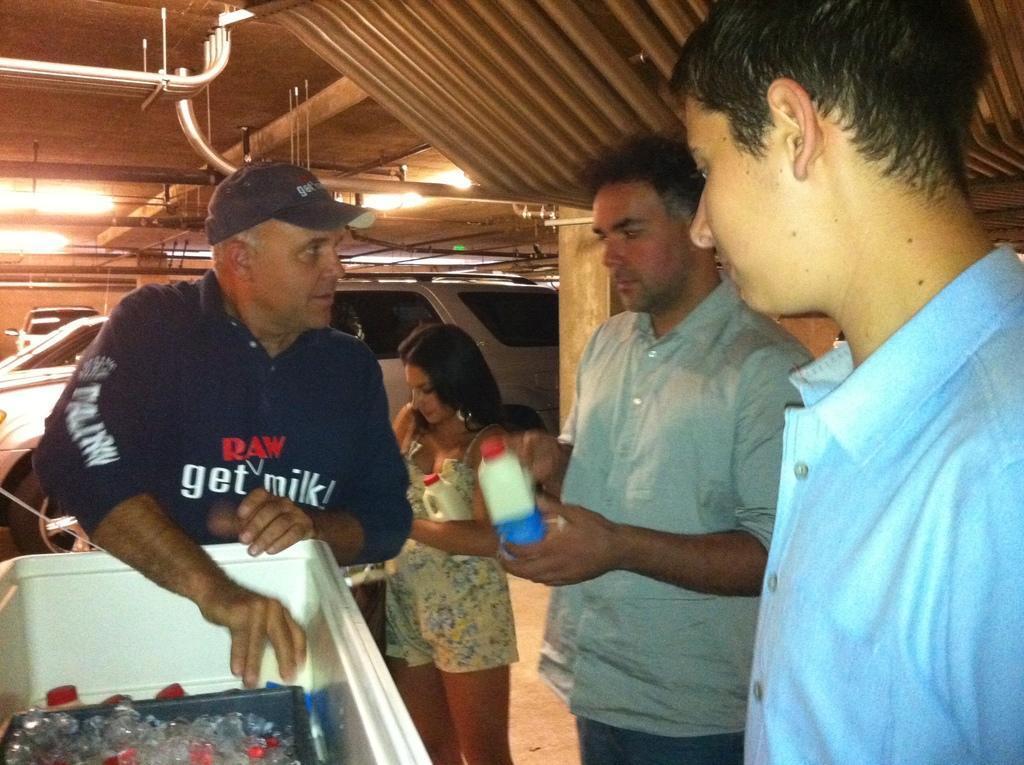In one or two sentences, can you explain what this image depicts? In the image we can see there are people standing, wearing clothes and some of them are holding an object in their hands, and one among them is wearing a cap. Here we can see the container and in the container we can see some objects. Here we can see floor, lights and vehicles. 